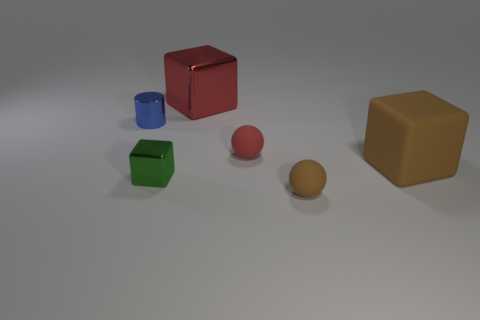What is the size of the metallic cube that is behind the small cylinder that is behind the big object that is in front of the big red metal block?
Provide a short and direct response. Large. There is a tiny blue object; does it have the same shape as the large red metal thing to the right of the small metallic cylinder?
Give a very brief answer. No. There is a green cube that is the same material as the tiny cylinder; what is its size?
Ensure brevity in your answer.  Small. Are there any other things of the same color as the big rubber cube?
Ensure brevity in your answer.  Yes. What material is the small block in front of the red rubber object that is on the left side of the big brown rubber cube on the right side of the small blue thing made of?
Keep it short and to the point. Metal. How many metallic things are green things or tiny brown blocks?
Offer a very short reply. 1. Is the color of the big matte object the same as the cylinder?
Offer a terse response. No. Is there any other thing that has the same material as the red ball?
Provide a short and direct response. Yes. What number of things are brown matte objects or shiny things to the right of the metal cylinder?
Offer a terse response. 4. Do the brown matte object that is in front of the matte block and the big matte object have the same size?
Keep it short and to the point. No. 